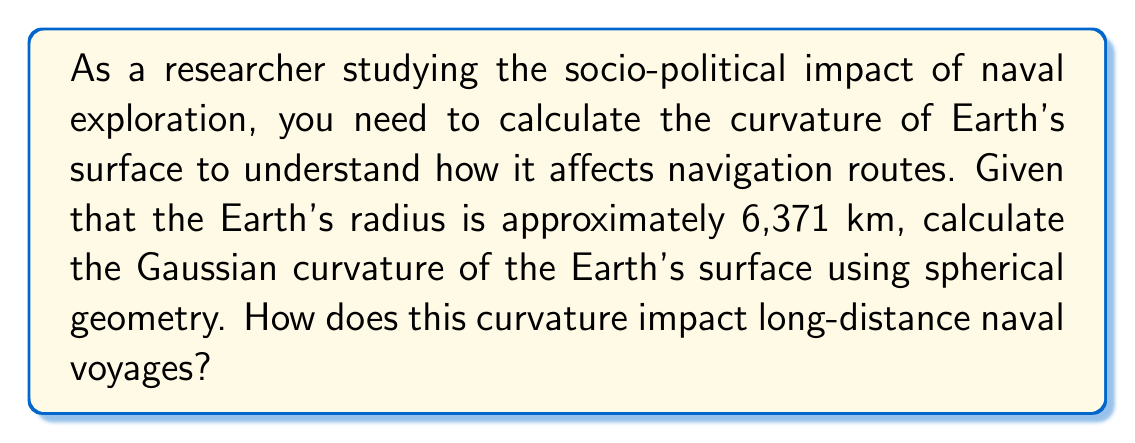What is the answer to this math problem? To calculate the Gaussian curvature of the Earth's surface using spherical geometry, we'll follow these steps:

1. Recall that for a sphere of radius $R$, the Gaussian curvature $K$ is constant and given by:

   $$K = \frac{1}{R^2}$$

2. We're given that the Earth's radius is approximately 6,371 km. Let's substitute this into our equation:

   $$K = \frac{1}{(6,371 \text{ km})^2}$$

3. Simplify:
   
   $$K = \frac{1}{40,589,641 \text{ km}^2} \approx 2.46 \times 10^{-8} \text{ km}^{-2}$$

4. To understand the impact on naval voyages, consider that this positive curvature means:

   a) The shortest path between two points (geodesic) is not a straight line but a great circle.
   
   b) The sum of angles in a spherical triangle exceeds 180°, affecting navigation calculations.
   
   c) The distance between meridians decreases as you move away from the equator, impacting east-west travel times.

5. These factors necessitated the development of specialized navigation techniques and tools, such as the sextant and Mercator projection maps, which had significant implications for naval exploration and, consequently, global socio-political dynamics.
Answer: $K \approx 2.46 \times 10^{-8} \text{ km}^{-2}$ 